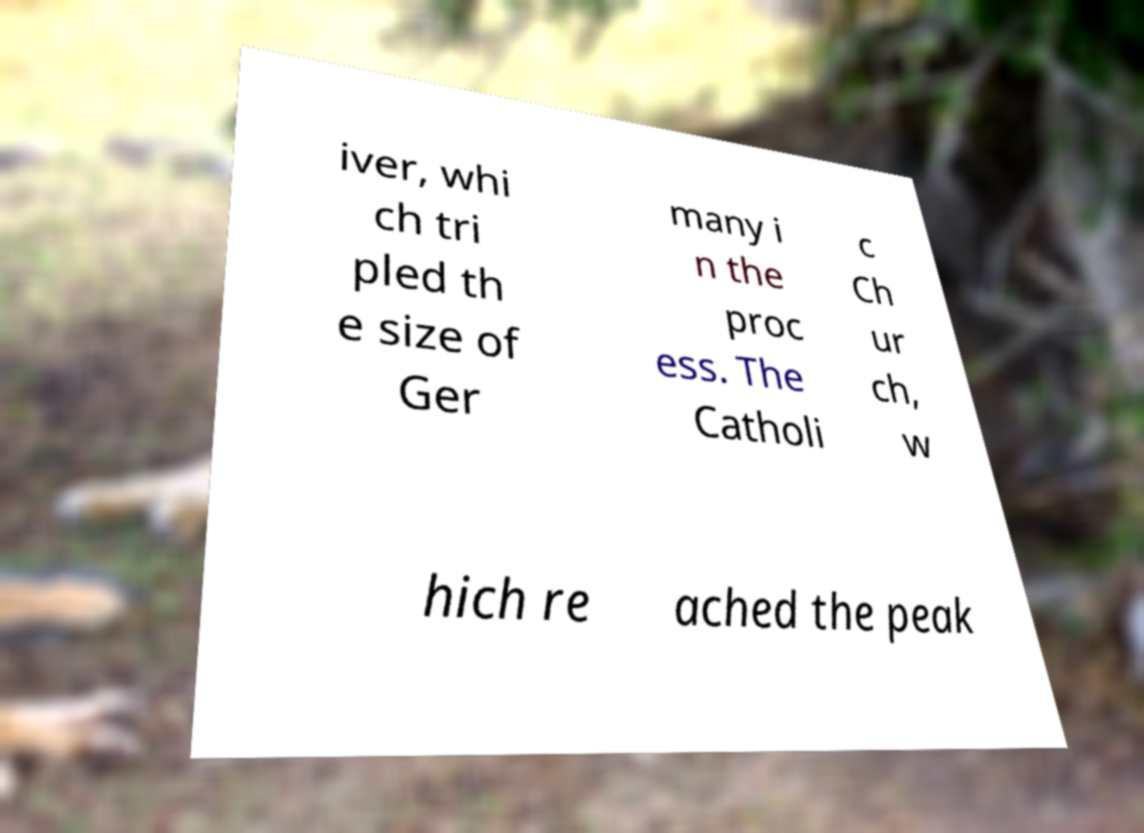I need the written content from this picture converted into text. Can you do that? iver, whi ch tri pled th e size of Ger many i n the proc ess. The Catholi c Ch ur ch, w hich re ached the peak 